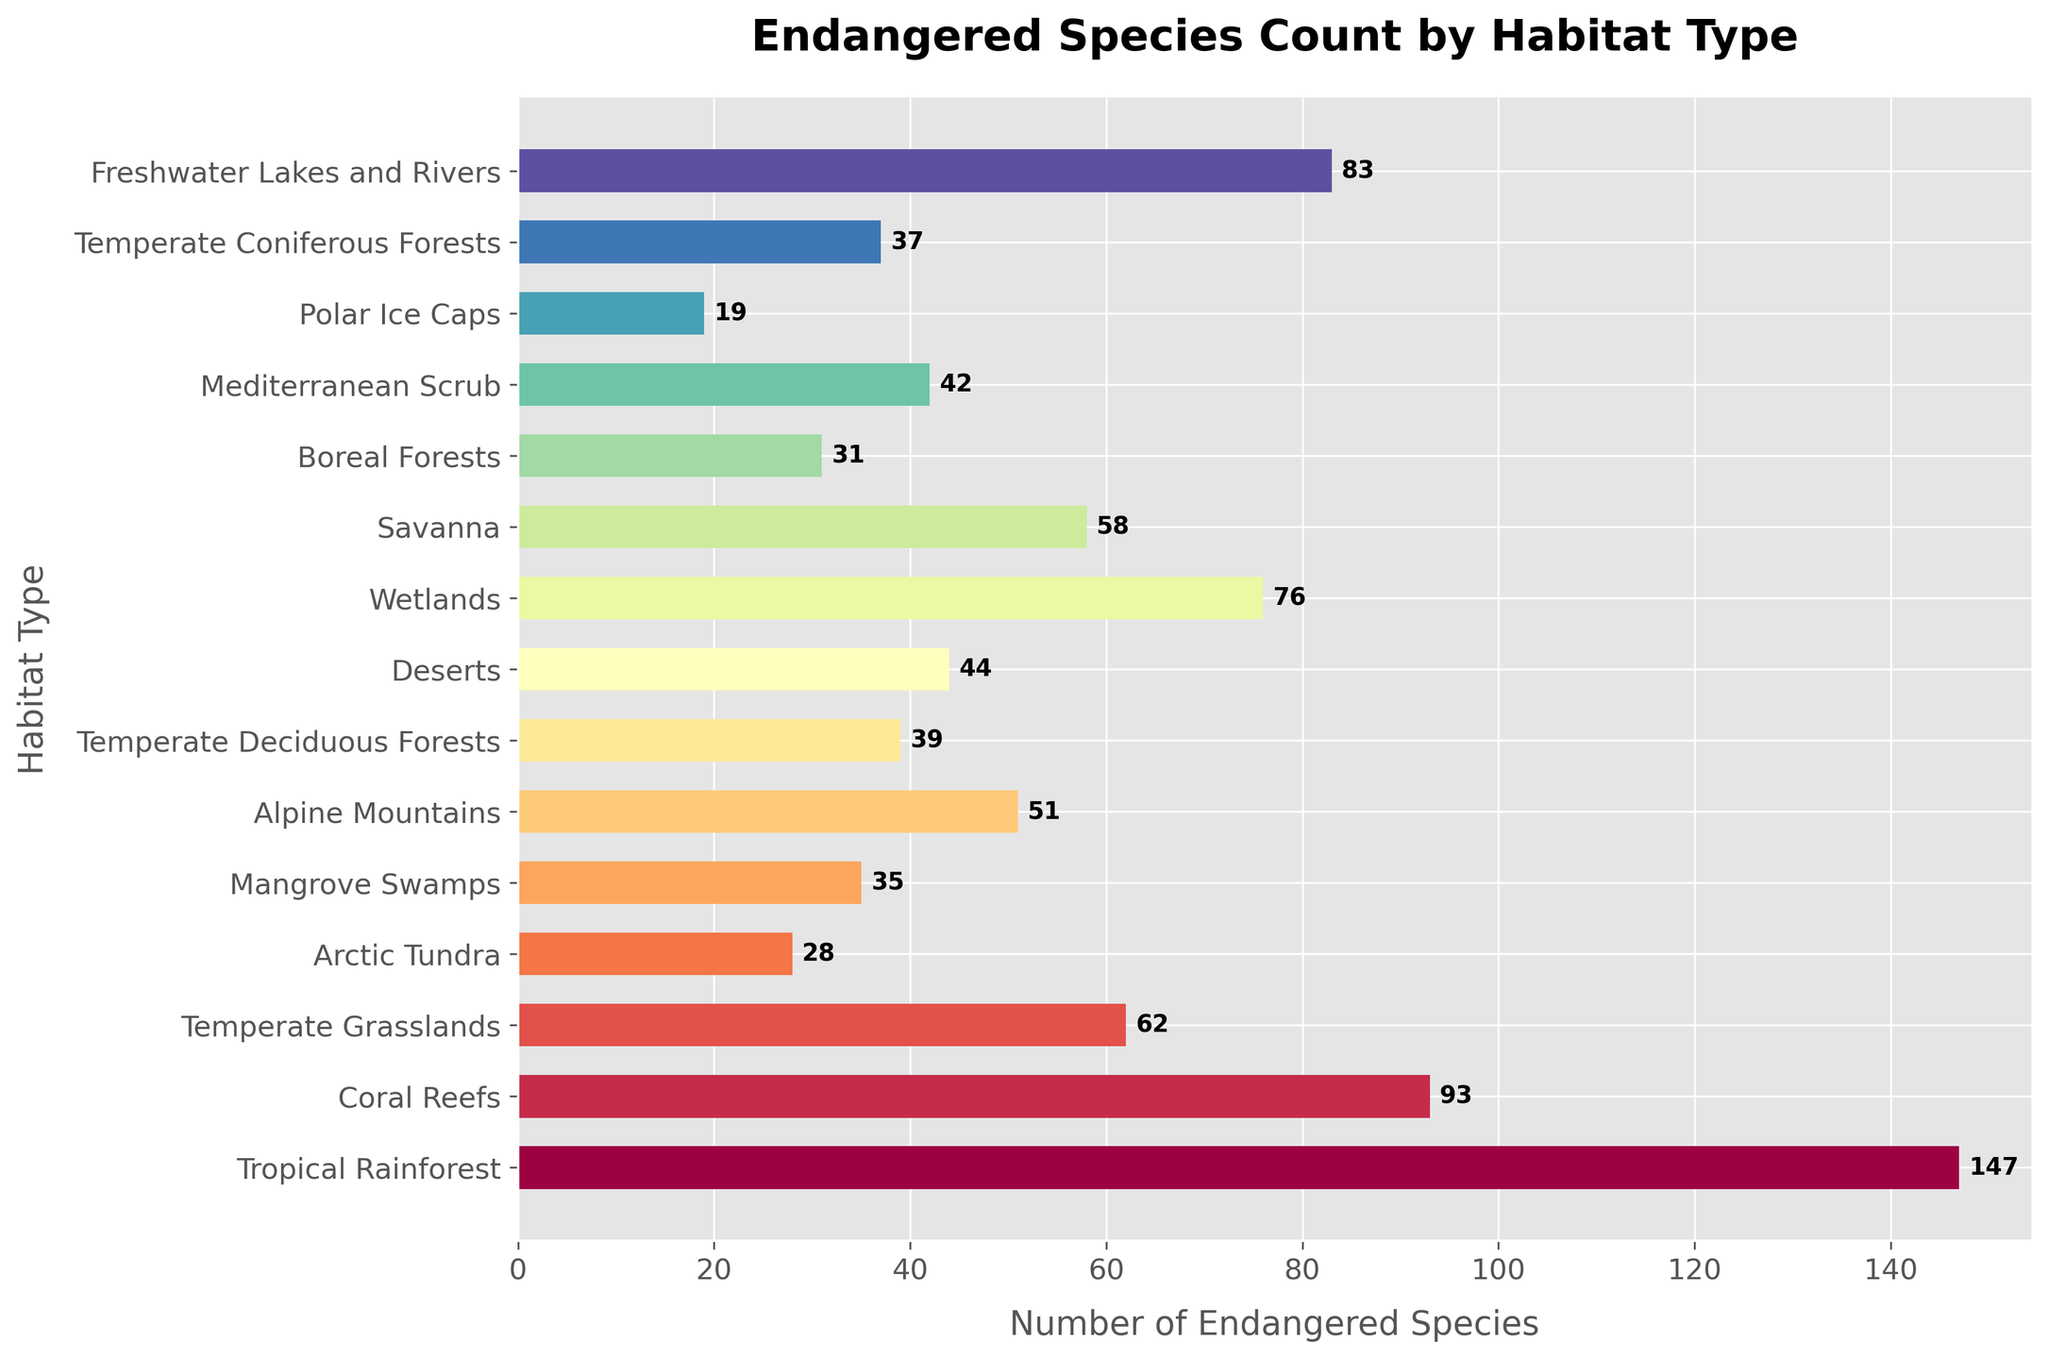Which habitat type has the highest number of endangered species? By visually examining the bars, the longest bar represents the habitat type with the highest number. Here, the Tropical Rainforest has the longest bar at 147.
Answer: Tropical Rainforest Which habitat type has the fewest endangered species? By visually checking the shortest bar, the Polar Ice Caps have the fewest endangered species with a count of 19.
Answer: Polar Ice Caps How many more endangered species are there in Tropical Rainforest compared to Arctic Tundra? The Tropical Rainforest has 147 endangered species, whereas the Arctic Tundra has 28. The difference is 147 - 28.
Answer: 119 What is the total number of endangered species in the Alpine Mountains and Mangrove Swamps combined? Sum the endangered species count for Alpine Mountains (51) and Mangrove Swamps (35). The total is 51 + 35.
Answer: 86 Which habitat types have more than 80 endangered species? Visual examination of bars longer than 80 identifies Tropical Rainforest (147), Coral Reefs (93), and Freshwater Lakes and Rivers (83).
Answer: Tropical Rainforest, Coral Reefs, Freshwater Lakes and Rivers Which habitat has a greater number of endangered species: Wetlands or Temperate Grasslands? Compare the bar lengths of Wetlands and Temperate Grasslands; Wetlands have 76, while Temperate Grasslands have 62.
Answer: Wetlands What is the average number of endangered species across all habitat types? Sum all endangered species counts and divide by the number of habitats: (147 + 93 + 62 + 28 + 35 + 51 + 39 + 44 + 76 + 58 + 31 + 42 + 19 + 37 + 83) / 15. The calculated sum is 845, and the number of habitats is 15, so the average is 845 / 15.
Answer: 56.33 How many habitat types have fewer than 50 endangered species? Count the bars shorter than 50: Arctic Tundra (28), Mangrove Swamps (35), Temperate Deciduous Forests (39), Deserts (44), Boreal Forests (31), Mediterranean Scrub (42), Temperate Coniferous Forests (37), and Polar Ice Caps (19).
Answer: 8 Which habitat type has nearly double the number of endangered species compared to Boreal Forests? Boreal Forests have 31 endangered species. Look for a habitat with approximately double this number (~62). Temperate Grasslands match this with 62.
Answer: Temperate Grasslands What is the difference in the number of endangered species between the habitat with the highest count and the habitat with the lowest count? The highest count is in Tropical Rainforest with 147, and the lowest count is in Polar Ice Caps with 19. The difference is 147 - 19.
Answer: 128 